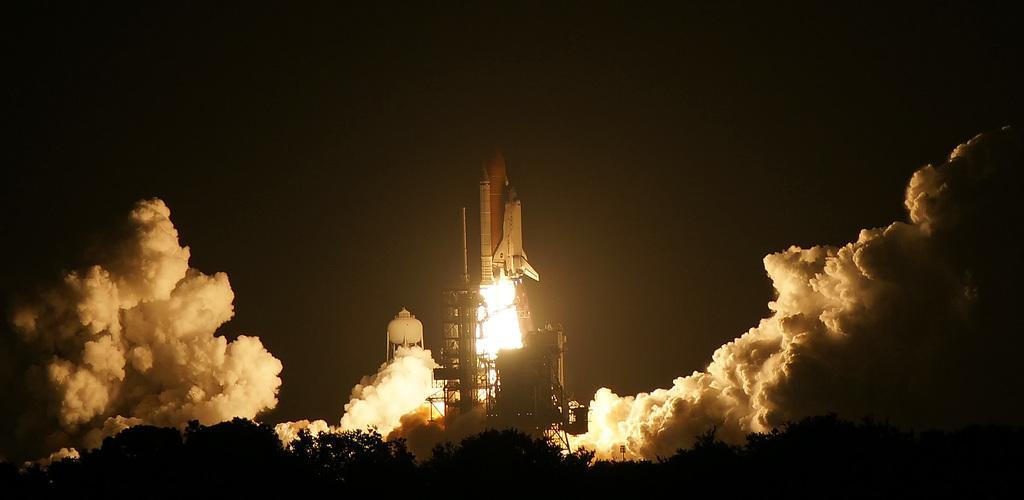Can you describe this image briefly? In this picture I can observe a rocket launching station in the middle of the picture. I can observe smoke on either sides of the picture. In the bottom of the picture there are some trees. The background is dark. 